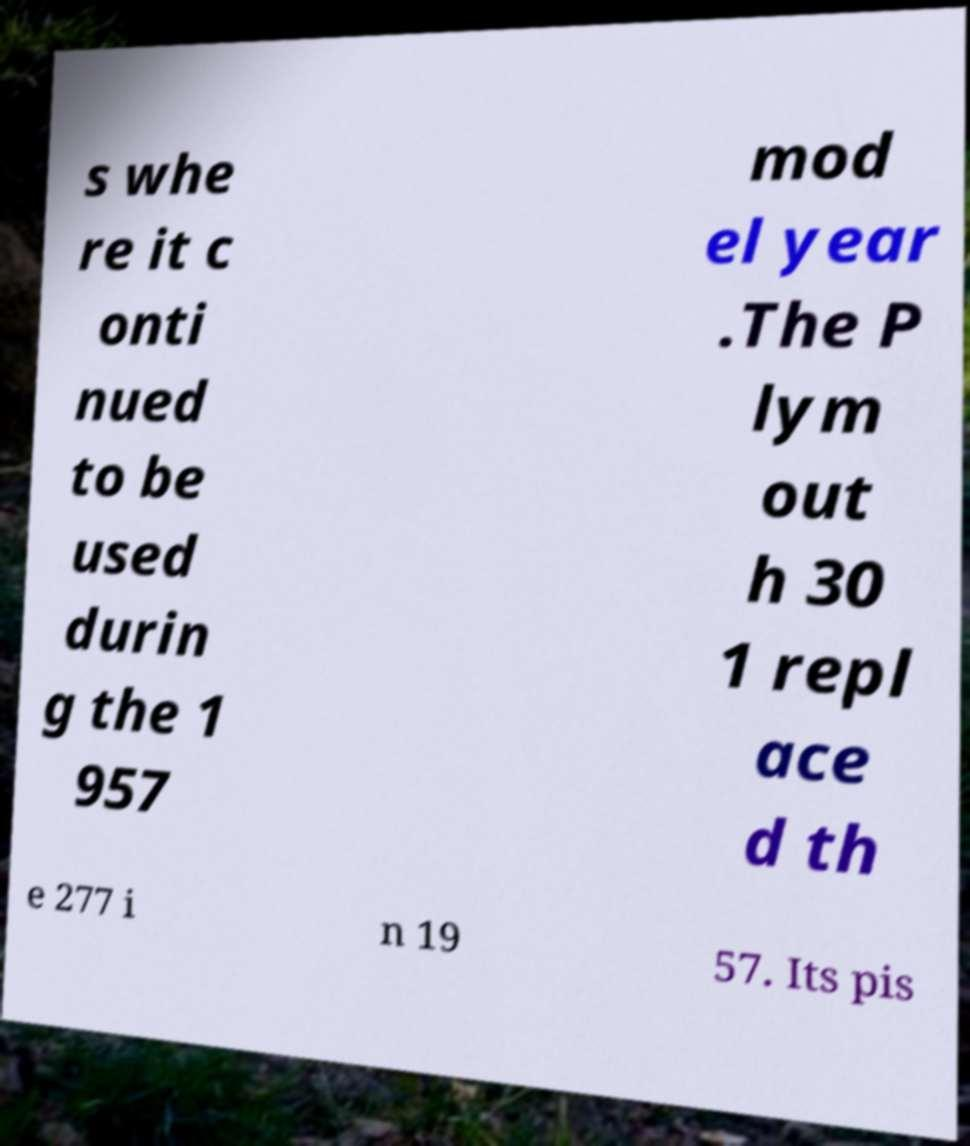Can you read and provide the text displayed in the image?This photo seems to have some interesting text. Can you extract and type it out for me? s whe re it c onti nued to be used durin g the 1 957 mod el year .The P lym out h 30 1 repl ace d th e 277 i n 19 57. Its pis 